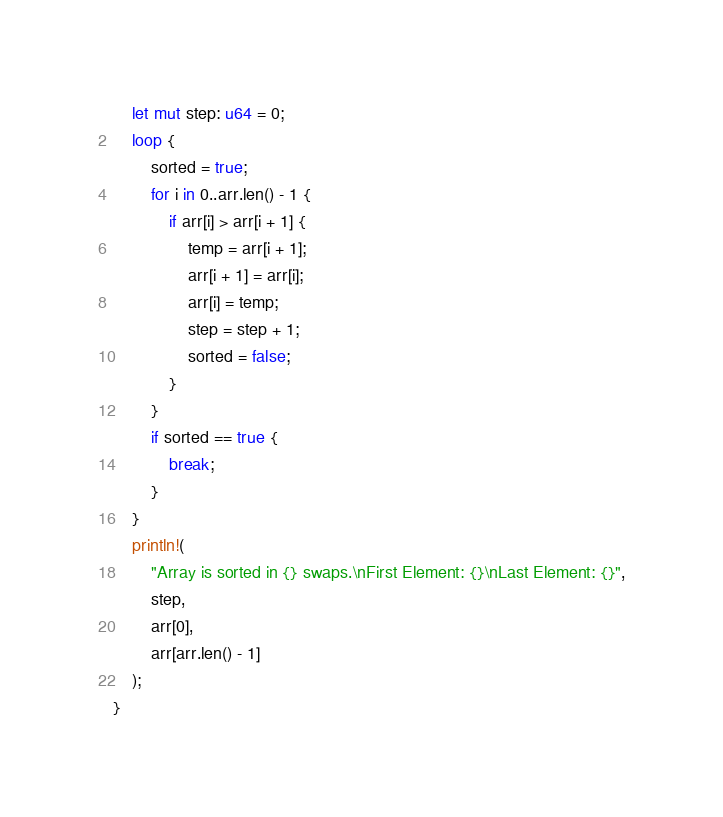Convert code to text. <code><loc_0><loc_0><loc_500><loc_500><_Rust_>    let mut step: u64 = 0;
    loop {
        sorted = true;
        for i in 0..arr.len() - 1 {
            if arr[i] > arr[i + 1] {
                temp = arr[i + 1];
                arr[i + 1] = arr[i];
                arr[i] = temp;
                step = step + 1;
                sorted = false;
            }
        }
        if sorted == true {
            break;
        }
    }
    println!(
        "Array is sorted in {} swaps.\nFirst Element: {}\nLast Element: {}",
        step,
        arr[0],
        arr[arr.len() - 1]
    );
}
</code> 